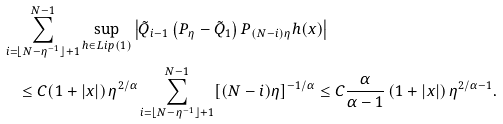<formula> <loc_0><loc_0><loc_500><loc_500>& \sum _ { i = \lfloor N - \eta ^ { - 1 } \rfloor + 1 } ^ { N - 1 } \sup _ { h \in L i p ( 1 ) } \left | \tilde { Q } _ { i - 1 } \left ( P _ { \eta } - \tilde { Q } _ { 1 } \right ) P _ { ( N - i ) \eta } h ( x ) \right | \\ & \quad \leq C ( 1 + | x | ) \, \eta ^ { 2 / \alpha } \sum _ { i = \lfloor N - \eta ^ { - 1 } \rfloor + 1 } ^ { N - 1 } [ ( N - i ) \eta ] ^ { - 1 / \alpha } \leq C \frac { \alpha } { \alpha - 1 } \, ( 1 + | x | ) \, \eta ^ { 2 / \alpha - 1 } .</formula> 